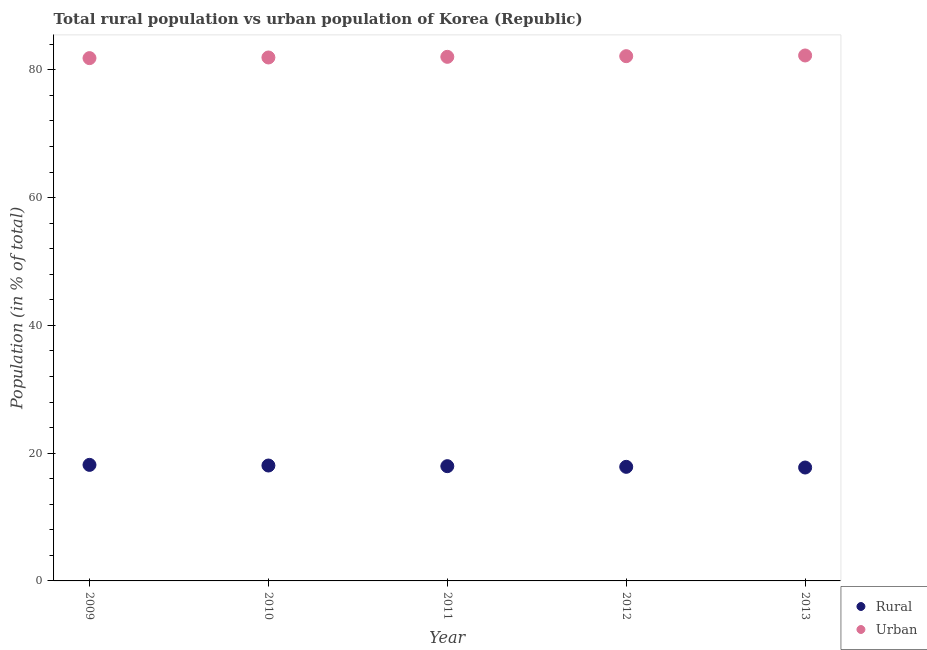What is the urban population in 2012?
Your response must be concise. 82.14. Across all years, what is the maximum rural population?
Your answer should be compact. 18.16. Across all years, what is the minimum urban population?
Keep it short and to the point. 81.83. In which year was the urban population maximum?
Offer a terse response. 2013. What is the total urban population in the graph?
Your response must be concise. 410.2. What is the difference between the rural population in 2009 and that in 2011?
Keep it short and to the point. 0.2. What is the difference between the urban population in 2010 and the rural population in 2009?
Offer a terse response. 63.77. What is the average rural population per year?
Offer a very short reply. 17.96. In the year 2010, what is the difference between the rural population and urban population?
Your answer should be compact. -63.87. In how many years, is the urban population greater than 64 %?
Make the answer very short. 5. What is the ratio of the rural population in 2010 to that in 2013?
Your answer should be compact. 1.02. What is the difference between the highest and the second highest urban population?
Ensure brevity in your answer.  0.11. What is the difference between the highest and the lowest urban population?
Your answer should be compact. 0.41. In how many years, is the urban population greater than the average urban population taken over all years?
Provide a short and direct response. 2. Is the sum of the urban population in 2012 and 2013 greater than the maximum rural population across all years?
Give a very brief answer. Yes. Does the rural population monotonically increase over the years?
Provide a succinct answer. No. Is the urban population strictly greater than the rural population over the years?
Offer a terse response. Yes. How many dotlines are there?
Offer a very short reply. 2. How many years are there in the graph?
Keep it short and to the point. 5. Does the graph contain any zero values?
Give a very brief answer. No. Does the graph contain grids?
Provide a succinct answer. No. Where does the legend appear in the graph?
Make the answer very short. Bottom right. How many legend labels are there?
Keep it short and to the point. 2. What is the title of the graph?
Offer a terse response. Total rural population vs urban population of Korea (Republic). Does "Methane" appear as one of the legend labels in the graph?
Offer a very short reply. No. What is the label or title of the X-axis?
Give a very brief answer. Year. What is the label or title of the Y-axis?
Keep it short and to the point. Population (in % of total). What is the Population (in % of total) in Rural in 2009?
Keep it short and to the point. 18.16. What is the Population (in % of total) in Urban in 2009?
Provide a succinct answer. 81.83. What is the Population (in % of total) of Rural in 2010?
Ensure brevity in your answer.  18.06. What is the Population (in % of total) of Urban in 2010?
Offer a terse response. 81.94. What is the Population (in % of total) in Rural in 2011?
Offer a terse response. 17.96. What is the Population (in % of total) in Urban in 2011?
Your answer should be compact. 82.04. What is the Population (in % of total) of Rural in 2012?
Your response must be concise. 17.86. What is the Population (in % of total) in Urban in 2012?
Make the answer very short. 82.14. What is the Population (in % of total) in Rural in 2013?
Ensure brevity in your answer.  17.75. What is the Population (in % of total) in Urban in 2013?
Your answer should be compact. 82.25. Across all years, what is the maximum Population (in % of total) in Rural?
Offer a very short reply. 18.16. Across all years, what is the maximum Population (in % of total) of Urban?
Provide a short and direct response. 82.25. Across all years, what is the minimum Population (in % of total) in Rural?
Make the answer very short. 17.75. Across all years, what is the minimum Population (in % of total) in Urban?
Offer a terse response. 81.83. What is the total Population (in % of total) in Rural in the graph?
Ensure brevity in your answer.  89.8. What is the total Population (in % of total) of Urban in the graph?
Keep it short and to the point. 410.2. What is the difference between the Population (in % of total) of Rural in 2009 and that in 2010?
Offer a very short reply. 0.1. What is the difference between the Population (in % of total) of Urban in 2009 and that in 2010?
Give a very brief answer. -0.1. What is the difference between the Population (in % of total) in Rural in 2009 and that in 2011?
Your answer should be compact. 0.2. What is the difference between the Population (in % of total) of Urban in 2009 and that in 2011?
Offer a terse response. -0.2. What is the difference between the Population (in % of total) of Rural in 2009 and that in 2012?
Your response must be concise. 0.31. What is the difference between the Population (in % of total) of Urban in 2009 and that in 2012?
Offer a terse response. -0.31. What is the difference between the Population (in % of total) in Rural in 2009 and that in 2013?
Your response must be concise. 0.41. What is the difference between the Population (in % of total) in Urban in 2009 and that in 2013?
Provide a short and direct response. -0.41. What is the difference between the Population (in % of total) of Rural in 2010 and that in 2011?
Provide a short and direct response. 0.1. What is the difference between the Population (in % of total) of Urban in 2010 and that in 2011?
Keep it short and to the point. -0.1. What is the difference between the Population (in % of total) of Rural in 2010 and that in 2012?
Keep it short and to the point. 0.2. What is the difference between the Population (in % of total) in Urban in 2010 and that in 2012?
Provide a short and direct response. -0.2. What is the difference between the Population (in % of total) of Rural in 2010 and that in 2013?
Your answer should be very brief. 0.31. What is the difference between the Population (in % of total) of Urban in 2010 and that in 2013?
Your answer should be very brief. -0.31. What is the difference between the Population (in % of total) of Rural in 2011 and that in 2012?
Give a very brief answer. 0.1. What is the difference between the Population (in % of total) in Urban in 2011 and that in 2012?
Keep it short and to the point. -0.1. What is the difference between the Population (in % of total) in Rural in 2011 and that in 2013?
Your answer should be compact. 0.21. What is the difference between the Population (in % of total) in Urban in 2011 and that in 2013?
Provide a short and direct response. -0.21. What is the difference between the Population (in % of total) of Rural in 2012 and that in 2013?
Give a very brief answer. 0.11. What is the difference between the Population (in % of total) in Urban in 2012 and that in 2013?
Offer a terse response. -0.11. What is the difference between the Population (in % of total) in Rural in 2009 and the Population (in % of total) in Urban in 2010?
Keep it short and to the point. -63.77. What is the difference between the Population (in % of total) of Rural in 2009 and the Population (in % of total) of Urban in 2011?
Your answer should be very brief. -63.87. What is the difference between the Population (in % of total) in Rural in 2009 and the Population (in % of total) in Urban in 2012?
Make the answer very short. -63.98. What is the difference between the Population (in % of total) of Rural in 2009 and the Population (in % of total) of Urban in 2013?
Provide a short and direct response. -64.08. What is the difference between the Population (in % of total) in Rural in 2010 and the Population (in % of total) in Urban in 2011?
Offer a terse response. -63.97. What is the difference between the Population (in % of total) in Rural in 2010 and the Population (in % of total) in Urban in 2012?
Offer a very short reply. -64.08. What is the difference between the Population (in % of total) in Rural in 2010 and the Population (in % of total) in Urban in 2013?
Ensure brevity in your answer.  -64.19. What is the difference between the Population (in % of total) in Rural in 2011 and the Population (in % of total) in Urban in 2012?
Your response must be concise. -64.18. What is the difference between the Population (in % of total) of Rural in 2011 and the Population (in % of total) of Urban in 2013?
Give a very brief answer. -64.29. What is the difference between the Population (in % of total) of Rural in 2012 and the Population (in % of total) of Urban in 2013?
Provide a succinct answer. -64.39. What is the average Population (in % of total) of Rural per year?
Make the answer very short. 17.96. What is the average Population (in % of total) of Urban per year?
Provide a short and direct response. 82.04. In the year 2009, what is the difference between the Population (in % of total) of Rural and Population (in % of total) of Urban?
Ensure brevity in your answer.  -63.67. In the year 2010, what is the difference between the Population (in % of total) in Rural and Population (in % of total) in Urban?
Provide a short and direct response. -63.87. In the year 2011, what is the difference between the Population (in % of total) in Rural and Population (in % of total) in Urban?
Your answer should be very brief. -64.07. In the year 2012, what is the difference between the Population (in % of total) of Rural and Population (in % of total) of Urban?
Offer a very short reply. -64.28. In the year 2013, what is the difference between the Population (in % of total) in Rural and Population (in % of total) in Urban?
Offer a terse response. -64.5. What is the ratio of the Population (in % of total) of Rural in 2009 to that in 2010?
Ensure brevity in your answer.  1.01. What is the ratio of the Population (in % of total) of Urban in 2009 to that in 2010?
Ensure brevity in your answer.  1. What is the ratio of the Population (in % of total) in Rural in 2009 to that in 2011?
Provide a short and direct response. 1.01. What is the ratio of the Population (in % of total) of Urban in 2009 to that in 2011?
Your answer should be compact. 1. What is the ratio of the Population (in % of total) in Rural in 2009 to that in 2012?
Provide a short and direct response. 1.02. What is the ratio of the Population (in % of total) of Rural in 2009 to that in 2013?
Your answer should be very brief. 1.02. What is the ratio of the Population (in % of total) in Rural in 2010 to that in 2011?
Ensure brevity in your answer.  1.01. What is the ratio of the Population (in % of total) in Rural in 2010 to that in 2012?
Your answer should be very brief. 1.01. What is the ratio of the Population (in % of total) in Rural in 2010 to that in 2013?
Provide a succinct answer. 1.02. What is the ratio of the Population (in % of total) in Urban in 2010 to that in 2013?
Your answer should be very brief. 1. What is the ratio of the Population (in % of total) in Rural in 2011 to that in 2013?
Make the answer very short. 1.01. What is the ratio of the Population (in % of total) of Urban in 2011 to that in 2013?
Your answer should be compact. 1. What is the ratio of the Population (in % of total) of Rural in 2012 to that in 2013?
Offer a very short reply. 1.01. What is the difference between the highest and the second highest Population (in % of total) in Rural?
Keep it short and to the point. 0.1. What is the difference between the highest and the second highest Population (in % of total) in Urban?
Provide a short and direct response. 0.11. What is the difference between the highest and the lowest Population (in % of total) in Rural?
Your answer should be compact. 0.41. What is the difference between the highest and the lowest Population (in % of total) of Urban?
Offer a very short reply. 0.41. 